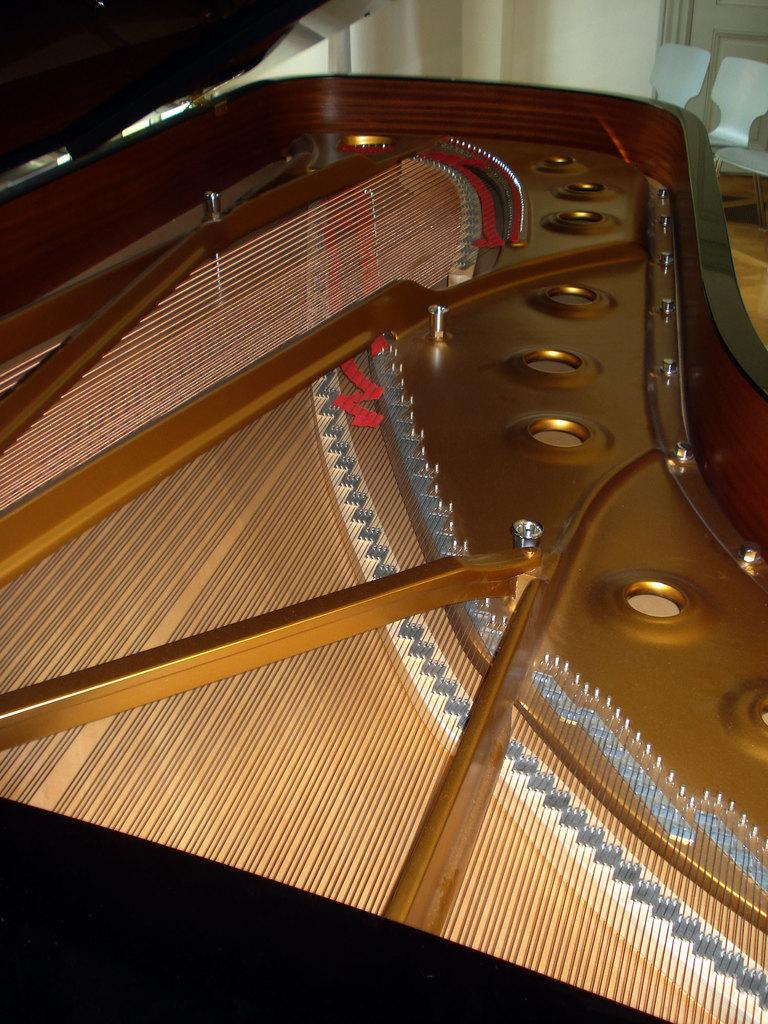What is the main subject of the image? The main subject of the image is the inner part of a piano. What can be found inside the piano? The piano has strings. What is visible in the background of the image? There is a wall and chairs in the background of the image. What type of hospital equipment can be seen in the image? There is no hospital equipment present in the image; it features the inner part of a piano. What color is the gold stick used by the pianist in the image? There is no gold stick or any indication of a pianist in the image; it shows the inner part of a piano with strings. 